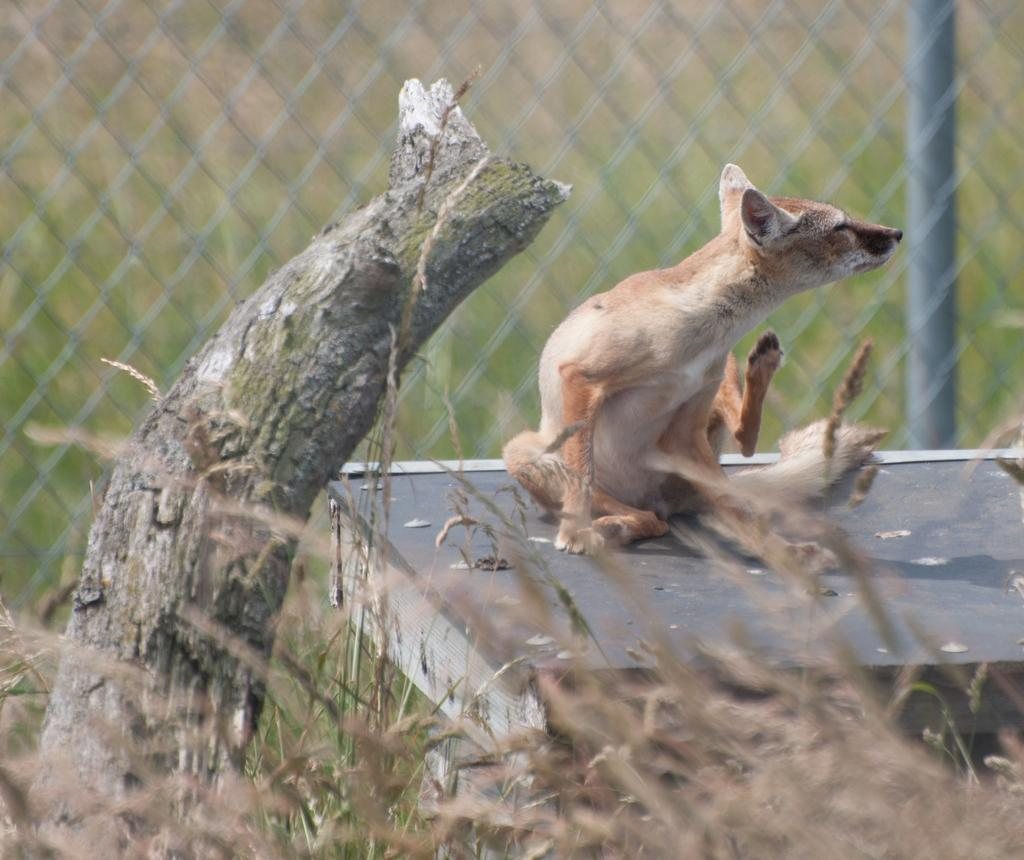What is the main subject of the image? There is an animal sitting on the surface in the image. What is located beside the animal? There is a tree trunk beside the animal. What is visible behind the animal? There is a fence behind the animal. What type of vegetation is present on the ground in the image? There is grass on the ground in the image. Can you see a fight happening between the animal and another creature in the image? There is no fight or any other creatures present in the image; it only features the animal sitting on the surface. Is the animal wearing a scarf in the image? There is no scarf or any clothing visible on the animal in the image. 